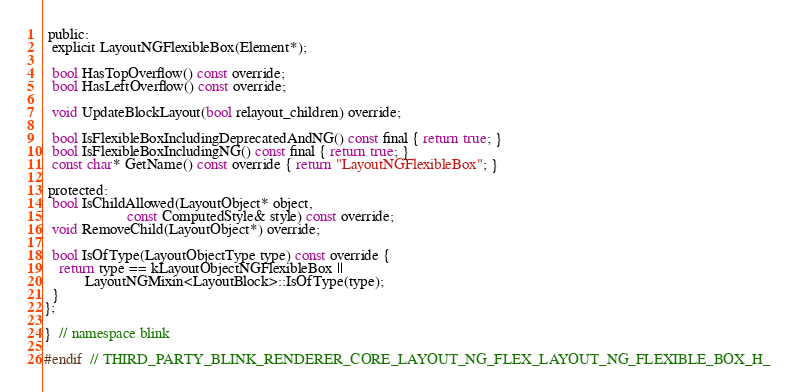<code> <loc_0><loc_0><loc_500><loc_500><_C_> public:
  explicit LayoutNGFlexibleBox(Element*);

  bool HasTopOverflow() const override;
  bool HasLeftOverflow() const override;

  void UpdateBlockLayout(bool relayout_children) override;

  bool IsFlexibleBoxIncludingDeprecatedAndNG() const final { return true; }
  bool IsFlexibleBoxIncludingNG() const final { return true; }
  const char* GetName() const override { return "LayoutNGFlexibleBox"; }

 protected:
  bool IsChildAllowed(LayoutObject* object,
                      const ComputedStyle& style) const override;
  void RemoveChild(LayoutObject*) override;

  bool IsOfType(LayoutObjectType type) const override {
    return type == kLayoutObjectNGFlexibleBox ||
           LayoutNGMixin<LayoutBlock>::IsOfType(type);
  }
};

}  // namespace blink

#endif  // THIRD_PARTY_BLINK_RENDERER_CORE_LAYOUT_NG_FLEX_LAYOUT_NG_FLEXIBLE_BOX_H_
</code> 